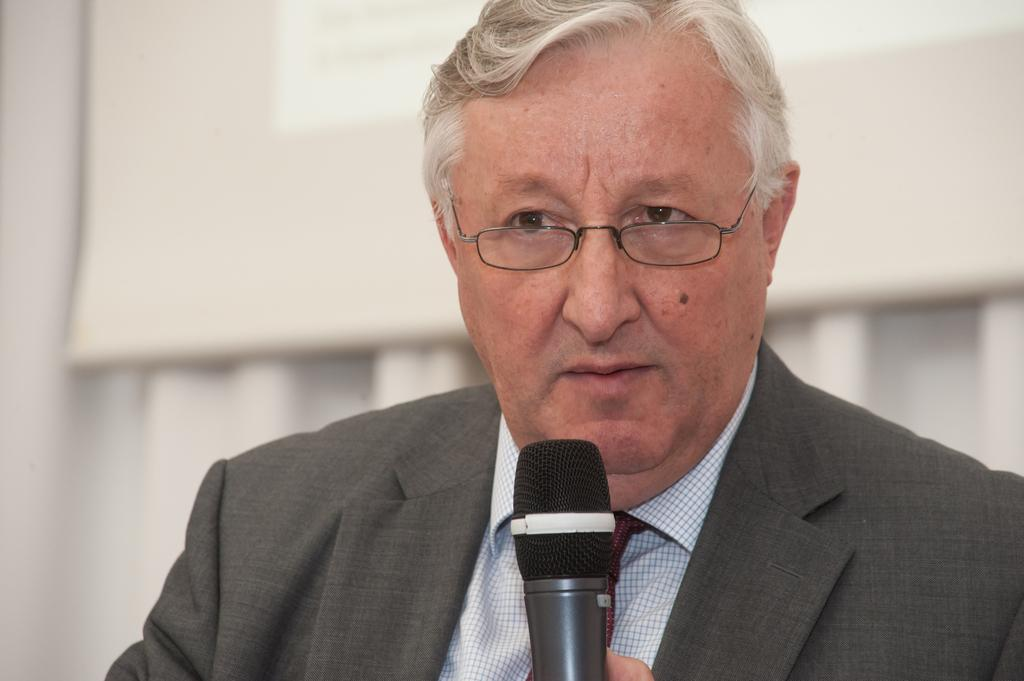What can be seen in the image? There is a person in the image. What is the person wearing? The person is wearing a black suit and spectacles. What is the person holding in his hand? The person is holding a microphone in his hand. What type of fan is visible in the image? There is no fan present in the image. Does the person in the image feel any shame? The image does not provide any information about the person's emotions or feelings, so it cannot be determined if they feel shame. 